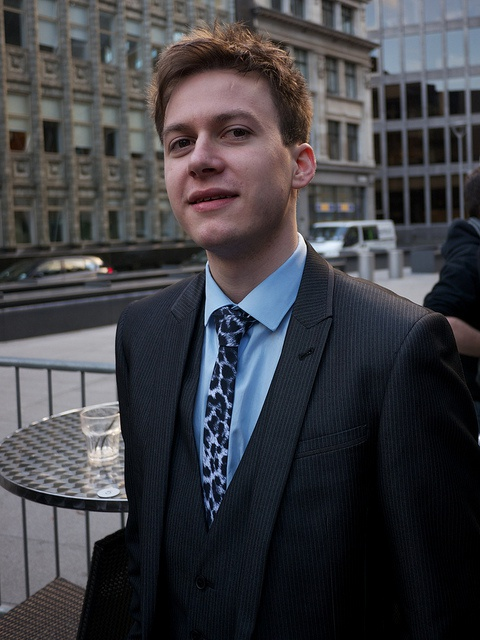Describe the objects in this image and their specific colors. I can see people in gray, black, and maroon tones, dining table in gray, darkgray, black, and lightgray tones, tie in gray, black, navy, and darkgray tones, chair in gray and black tones, and truck in gray, darkgray, and black tones in this image. 